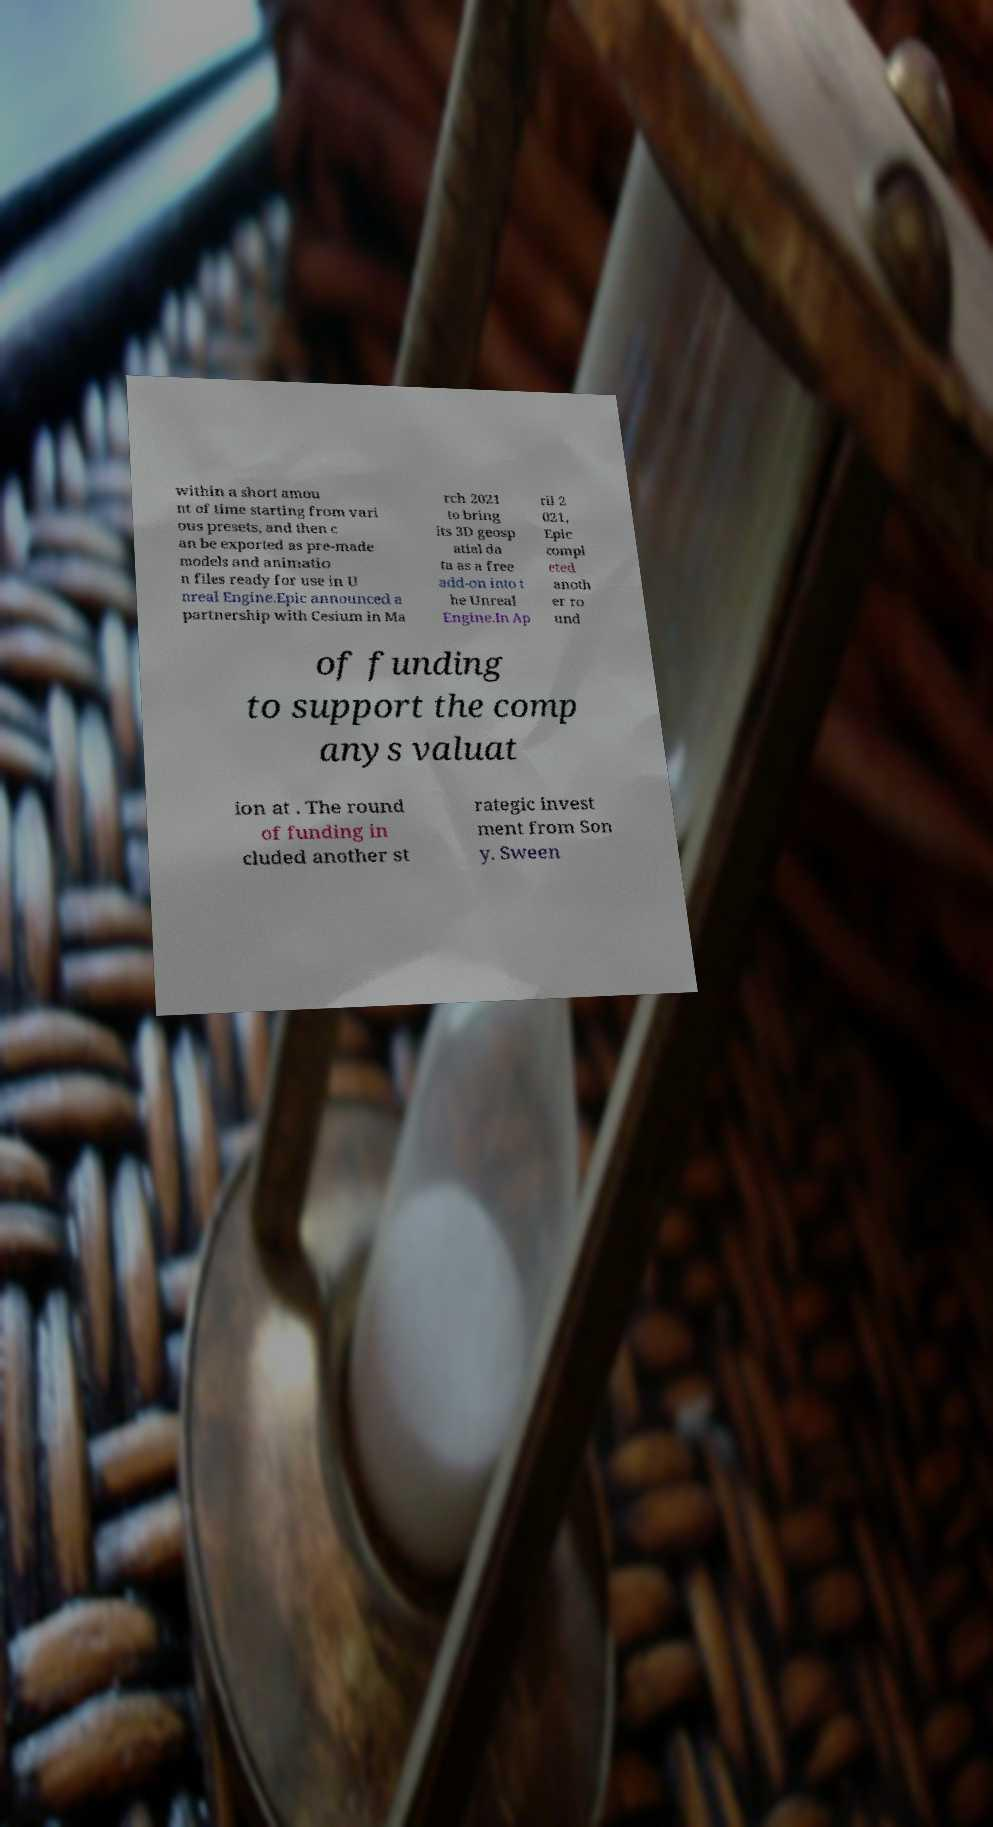Could you extract and type out the text from this image? within a short amou nt of time starting from vari ous presets, and then c an be exported as pre-made models and animatio n files ready for use in U nreal Engine.Epic announced a partnership with Cesium in Ma rch 2021 to bring its 3D geosp atial da ta as a free add-on into t he Unreal Engine.In Ap ril 2 021, Epic compl eted anoth er ro und of funding to support the comp anys valuat ion at . The round of funding in cluded another st rategic invest ment from Son y. Sween 